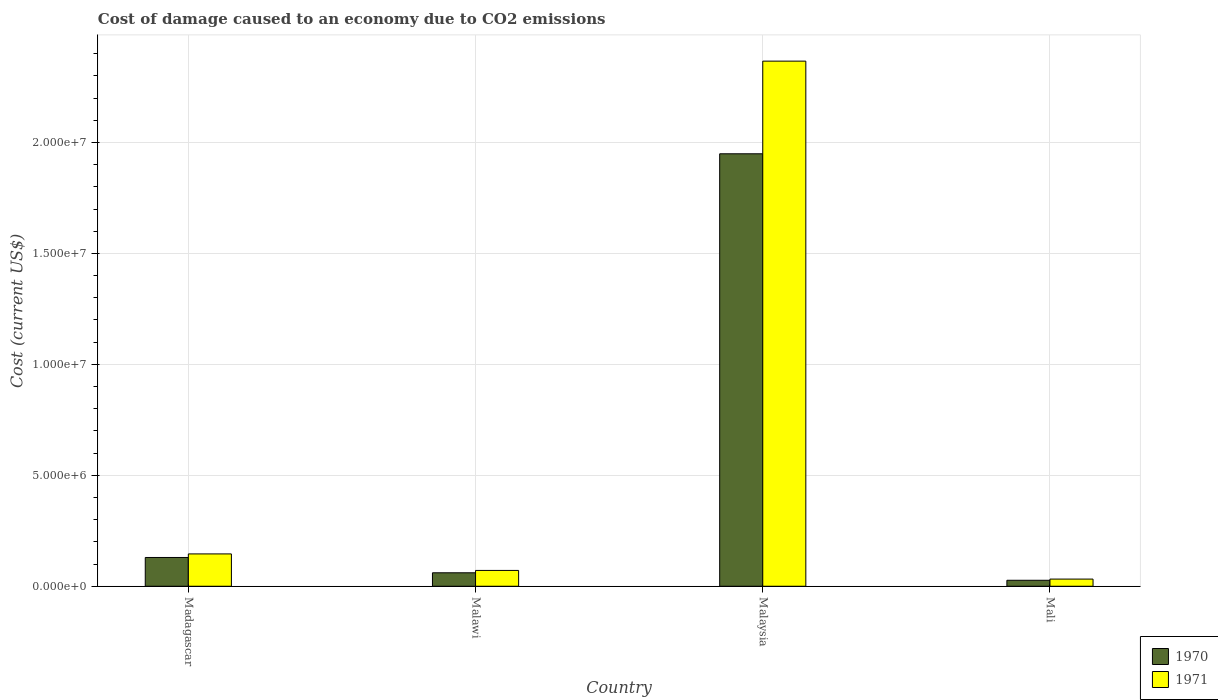How many groups of bars are there?
Your answer should be very brief. 4. Are the number of bars per tick equal to the number of legend labels?
Your answer should be compact. Yes. How many bars are there on the 2nd tick from the left?
Offer a terse response. 2. How many bars are there on the 4th tick from the right?
Keep it short and to the point. 2. What is the label of the 3rd group of bars from the left?
Give a very brief answer. Malaysia. In how many cases, is the number of bars for a given country not equal to the number of legend labels?
Your answer should be compact. 0. What is the cost of damage caused due to CO2 emissisons in 1970 in Malaysia?
Keep it short and to the point. 1.95e+07. Across all countries, what is the maximum cost of damage caused due to CO2 emissisons in 1970?
Your answer should be compact. 1.95e+07. Across all countries, what is the minimum cost of damage caused due to CO2 emissisons in 1971?
Ensure brevity in your answer.  3.23e+05. In which country was the cost of damage caused due to CO2 emissisons in 1971 maximum?
Provide a short and direct response. Malaysia. In which country was the cost of damage caused due to CO2 emissisons in 1970 minimum?
Make the answer very short. Mali. What is the total cost of damage caused due to CO2 emissisons in 1970 in the graph?
Provide a short and direct response. 2.17e+07. What is the difference between the cost of damage caused due to CO2 emissisons in 1970 in Madagascar and that in Malawi?
Your response must be concise. 6.90e+05. What is the difference between the cost of damage caused due to CO2 emissisons in 1971 in Malawi and the cost of damage caused due to CO2 emissisons in 1970 in Mali?
Give a very brief answer. 4.44e+05. What is the average cost of damage caused due to CO2 emissisons in 1971 per country?
Your answer should be very brief. 6.54e+06. What is the difference between the cost of damage caused due to CO2 emissisons of/in 1970 and cost of damage caused due to CO2 emissisons of/in 1971 in Madagascar?
Your response must be concise. -1.60e+05. In how many countries, is the cost of damage caused due to CO2 emissisons in 1971 greater than 16000000 US$?
Provide a short and direct response. 1. What is the ratio of the cost of damage caused due to CO2 emissisons in 1971 in Madagascar to that in Mali?
Offer a terse response. 4.52. What is the difference between the highest and the second highest cost of damage caused due to CO2 emissisons in 1970?
Provide a succinct answer. 6.90e+05. What is the difference between the highest and the lowest cost of damage caused due to CO2 emissisons in 1971?
Provide a succinct answer. 2.33e+07. Is the sum of the cost of damage caused due to CO2 emissisons in 1970 in Madagascar and Malawi greater than the maximum cost of damage caused due to CO2 emissisons in 1971 across all countries?
Provide a succinct answer. No. What is the difference between two consecutive major ticks on the Y-axis?
Make the answer very short. 5.00e+06. Where does the legend appear in the graph?
Make the answer very short. Bottom right. What is the title of the graph?
Provide a short and direct response. Cost of damage caused to an economy due to CO2 emissions. What is the label or title of the Y-axis?
Provide a short and direct response. Cost (current US$). What is the Cost (current US$) of 1970 in Madagascar?
Provide a succinct answer. 1.30e+06. What is the Cost (current US$) in 1971 in Madagascar?
Your answer should be compact. 1.46e+06. What is the Cost (current US$) of 1970 in Malawi?
Offer a very short reply. 6.07e+05. What is the Cost (current US$) in 1971 in Malawi?
Provide a short and direct response. 7.13e+05. What is the Cost (current US$) in 1970 in Malaysia?
Ensure brevity in your answer.  1.95e+07. What is the Cost (current US$) in 1971 in Malaysia?
Offer a very short reply. 2.37e+07. What is the Cost (current US$) of 1970 in Mali?
Provide a short and direct response. 2.69e+05. What is the Cost (current US$) in 1971 in Mali?
Offer a very short reply. 3.23e+05. Across all countries, what is the maximum Cost (current US$) in 1970?
Your answer should be very brief. 1.95e+07. Across all countries, what is the maximum Cost (current US$) in 1971?
Keep it short and to the point. 2.37e+07. Across all countries, what is the minimum Cost (current US$) of 1970?
Make the answer very short. 2.69e+05. Across all countries, what is the minimum Cost (current US$) in 1971?
Give a very brief answer. 3.23e+05. What is the total Cost (current US$) in 1970 in the graph?
Your response must be concise. 2.17e+07. What is the total Cost (current US$) in 1971 in the graph?
Make the answer very short. 2.62e+07. What is the difference between the Cost (current US$) in 1970 in Madagascar and that in Malawi?
Offer a terse response. 6.90e+05. What is the difference between the Cost (current US$) of 1971 in Madagascar and that in Malawi?
Offer a very short reply. 7.44e+05. What is the difference between the Cost (current US$) of 1970 in Madagascar and that in Malaysia?
Ensure brevity in your answer.  -1.82e+07. What is the difference between the Cost (current US$) in 1971 in Madagascar and that in Malaysia?
Provide a succinct answer. -2.22e+07. What is the difference between the Cost (current US$) in 1970 in Madagascar and that in Mali?
Provide a succinct answer. 1.03e+06. What is the difference between the Cost (current US$) of 1971 in Madagascar and that in Mali?
Ensure brevity in your answer.  1.13e+06. What is the difference between the Cost (current US$) of 1970 in Malawi and that in Malaysia?
Make the answer very short. -1.89e+07. What is the difference between the Cost (current US$) of 1971 in Malawi and that in Malaysia?
Your response must be concise. -2.30e+07. What is the difference between the Cost (current US$) in 1970 in Malawi and that in Mali?
Your answer should be very brief. 3.38e+05. What is the difference between the Cost (current US$) in 1971 in Malawi and that in Mali?
Make the answer very short. 3.90e+05. What is the difference between the Cost (current US$) in 1970 in Malaysia and that in Mali?
Ensure brevity in your answer.  1.92e+07. What is the difference between the Cost (current US$) of 1971 in Malaysia and that in Mali?
Give a very brief answer. 2.33e+07. What is the difference between the Cost (current US$) of 1970 in Madagascar and the Cost (current US$) of 1971 in Malawi?
Your answer should be very brief. 5.84e+05. What is the difference between the Cost (current US$) in 1970 in Madagascar and the Cost (current US$) in 1971 in Malaysia?
Give a very brief answer. -2.24e+07. What is the difference between the Cost (current US$) in 1970 in Madagascar and the Cost (current US$) in 1971 in Mali?
Make the answer very short. 9.74e+05. What is the difference between the Cost (current US$) of 1970 in Malawi and the Cost (current US$) of 1971 in Malaysia?
Ensure brevity in your answer.  -2.31e+07. What is the difference between the Cost (current US$) in 1970 in Malawi and the Cost (current US$) in 1971 in Mali?
Give a very brief answer. 2.84e+05. What is the difference between the Cost (current US$) of 1970 in Malaysia and the Cost (current US$) of 1971 in Mali?
Provide a succinct answer. 1.92e+07. What is the average Cost (current US$) in 1970 per country?
Your answer should be very brief. 5.42e+06. What is the average Cost (current US$) in 1971 per country?
Give a very brief answer. 6.54e+06. What is the difference between the Cost (current US$) in 1970 and Cost (current US$) in 1971 in Madagascar?
Provide a short and direct response. -1.60e+05. What is the difference between the Cost (current US$) of 1970 and Cost (current US$) of 1971 in Malawi?
Give a very brief answer. -1.06e+05. What is the difference between the Cost (current US$) in 1970 and Cost (current US$) in 1971 in Malaysia?
Your response must be concise. -4.18e+06. What is the difference between the Cost (current US$) in 1970 and Cost (current US$) in 1971 in Mali?
Keep it short and to the point. -5.34e+04. What is the ratio of the Cost (current US$) of 1970 in Madagascar to that in Malawi?
Keep it short and to the point. 2.14. What is the ratio of the Cost (current US$) of 1971 in Madagascar to that in Malawi?
Keep it short and to the point. 2.04. What is the ratio of the Cost (current US$) of 1970 in Madagascar to that in Malaysia?
Your answer should be very brief. 0.07. What is the ratio of the Cost (current US$) in 1971 in Madagascar to that in Malaysia?
Provide a succinct answer. 0.06. What is the ratio of the Cost (current US$) of 1970 in Madagascar to that in Mali?
Your answer should be compact. 4.82. What is the ratio of the Cost (current US$) in 1971 in Madagascar to that in Mali?
Your response must be concise. 4.52. What is the ratio of the Cost (current US$) in 1970 in Malawi to that in Malaysia?
Your response must be concise. 0.03. What is the ratio of the Cost (current US$) in 1971 in Malawi to that in Malaysia?
Give a very brief answer. 0.03. What is the ratio of the Cost (current US$) of 1970 in Malawi to that in Mali?
Offer a very short reply. 2.25. What is the ratio of the Cost (current US$) in 1971 in Malawi to that in Mali?
Keep it short and to the point. 2.21. What is the ratio of the Cost (current US$) in 1970 in Malaysia to that in Mali?
Your answer should be compact. 72.4. What is the ratio of the Cost (current US$) in 1971 in Malaysia to that in Mali?
Give a very brief answer. 73.35. What is the difference between the highest and the second highest Cost (current US$) of 1970?
Make the answer very short. 1.82e+07. What is the difference between the highest and the second highest Cost (current US$) of 1971?
Offer a terse response. 2.22e+07. What is the difference between the highest and the lowest Cost (current US$) of 1970?
Keep it short and to the point. 1.92e+07. What is the difference between the highest and the lowest Cost (current US$) in 1971?
Offer a terse response. 2.33e+07. 